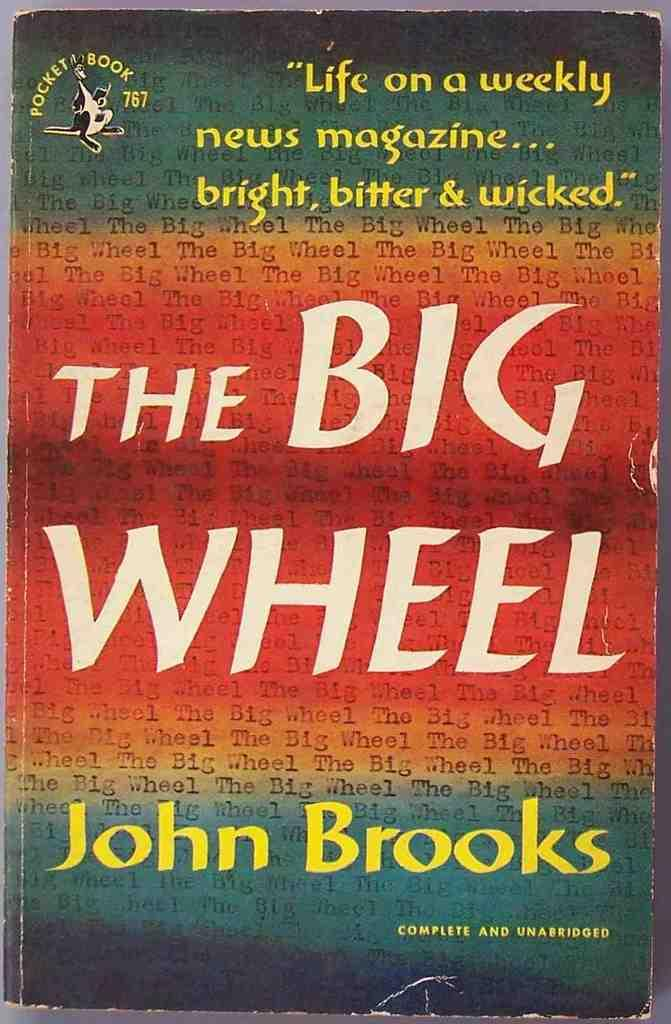<image>
Relay a brief, clear account of the picture shown. Cover for The Big Wheel by John Brooks in green and orange. 